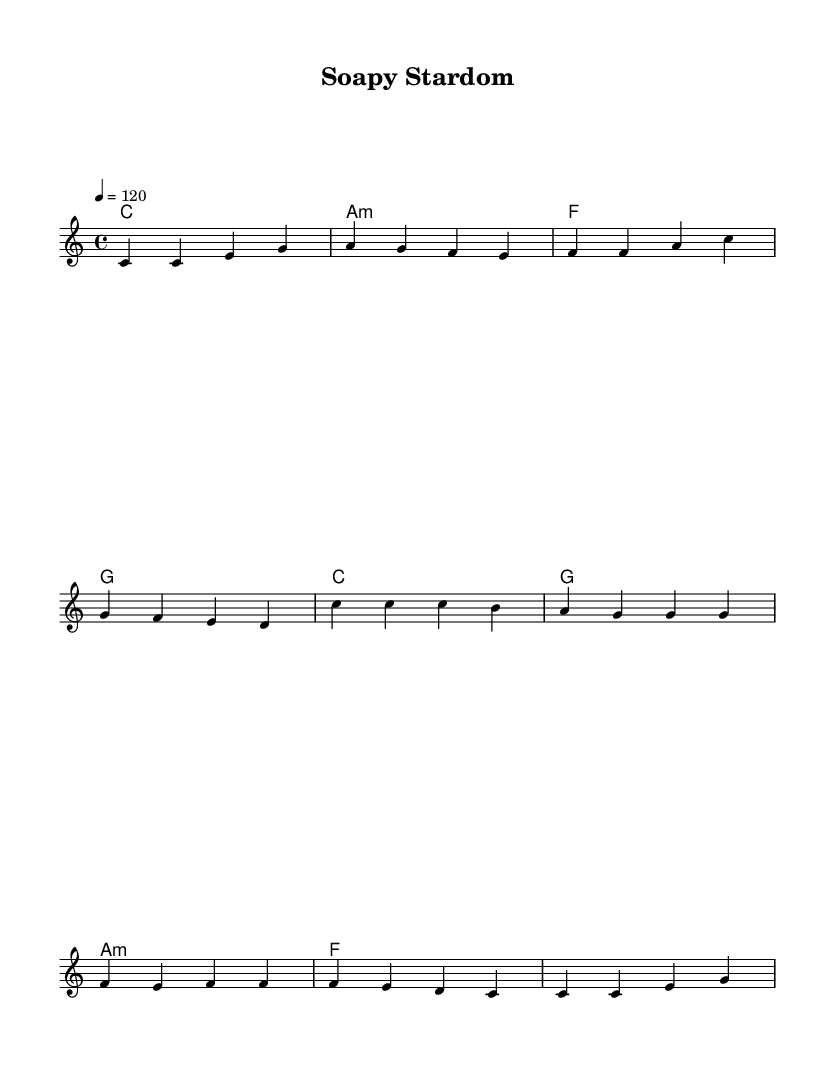What is the key signature of this music? The key signature is indicated by the note structure in the music and corresponds to C major, which has no sharps or flats.
Answer: C major What is the time signature of this piece? The time signature, seen at the beginning of the score, is 4/4, which means there are four beats in a measure.
Answer: 4/4 What is the tempo marking of the piece? The tempo marking indicates that the piece should be played at a speed of 120 beats per minute, specified in the score.
Answer: 120 How many measures are in the verse? Counting each segment of music in the verse, there are four measures, as separated by the vertical lines.
Answer: 4 What is the melody for the chorus starting note? The melody for the chorus begins on the note C, which is indicated as the first note of the chorus section in the sheet music.
Answer: C What chord follows the last measure of the verse? The final chord of the verse is a G chord, as indicated at the end of the verse measures.
Answer: G How many lines are present in the lyrics of the chorus? The lyrics for the chorus are structured across two lines, as shown in the lyric mode section of the sheet music.
Answer: 2 